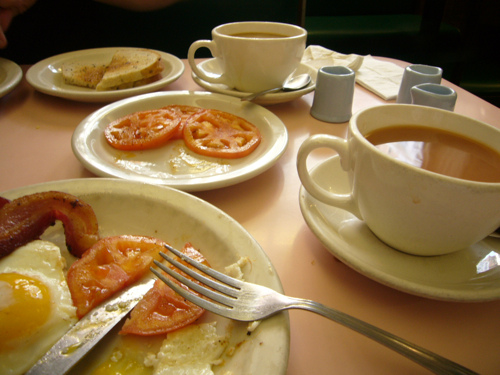<image>
Is the knife on the plate? No. The knife is not positioned on the plate. They may be near each other, but the knife is not supported by or resting on top of the plate. 